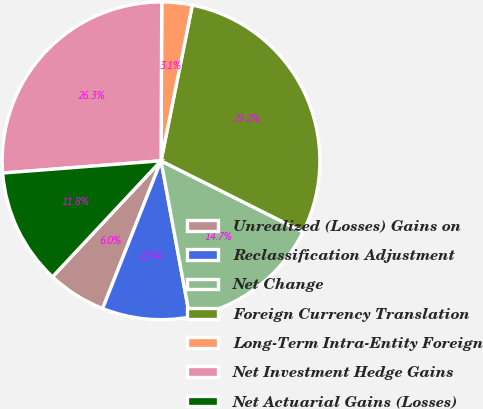<chart> <loc_0><loc_0><loc_500><loc_500><pie_chart><fcel>Unrealized (Losses) Gains on<fcel>Reclassification Adjustment<fcel>Net Change<fcel>Foreign Currency Translation<fcel>Long-Term Intra-Entity Foreign<fcel>Net Investment Hedge Gains<fcel>Net Actuarial Gains (Losses)<nl><fcel>5.98%<fcel>8.89%<fcel>14.71%<fcel>29.24%<fcel>3.08%<fcel>26.3%<fcel>11.8%<nl></chart> 